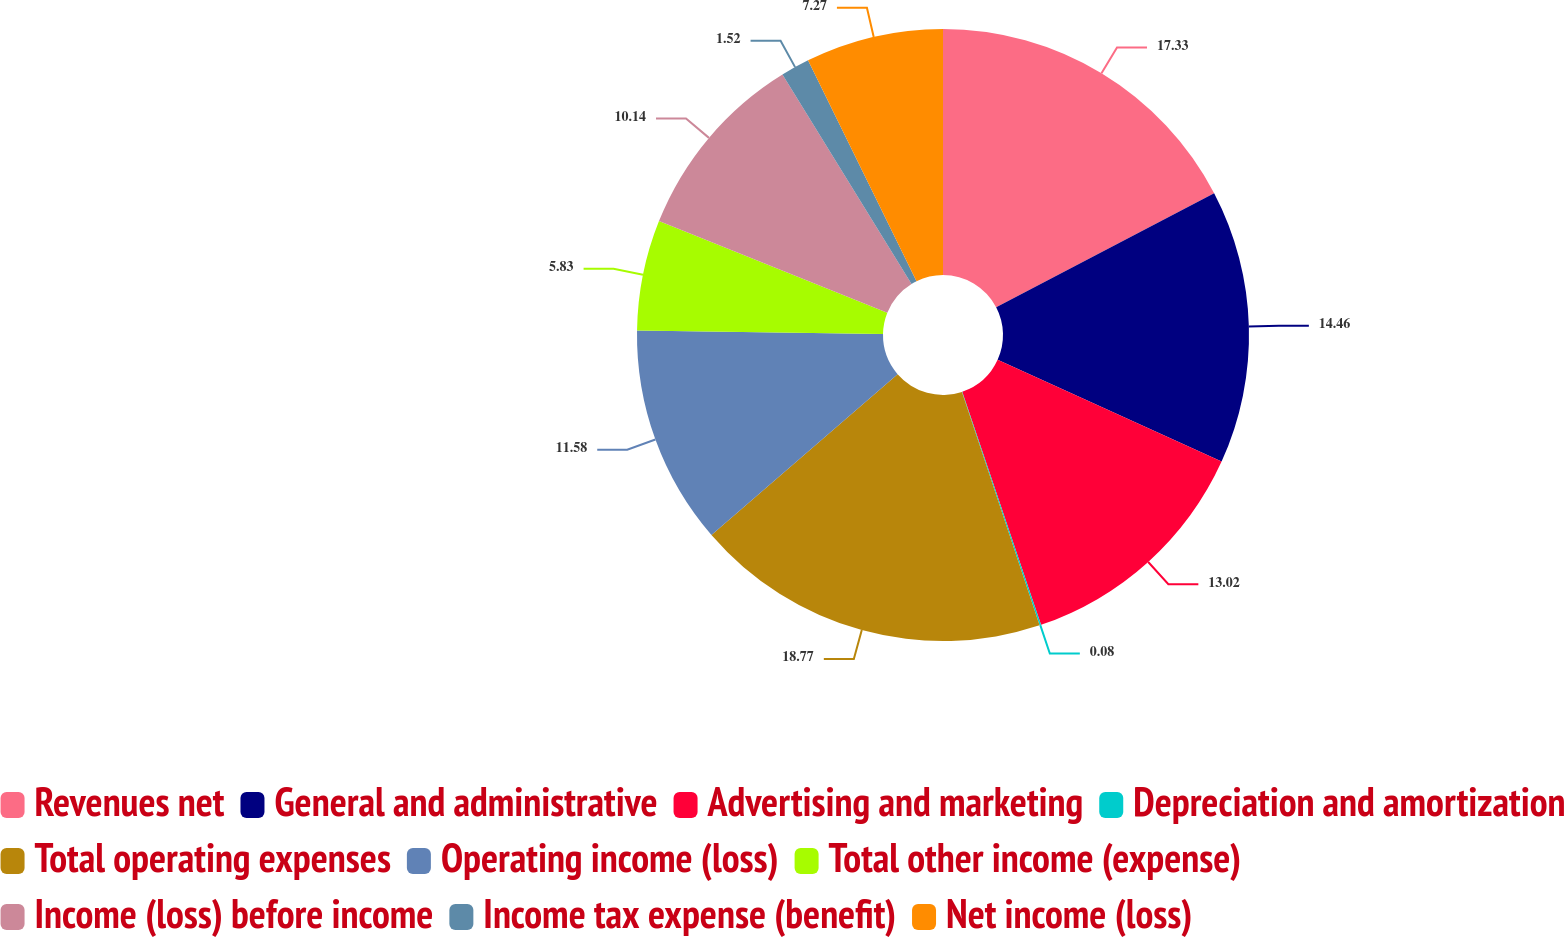<chart> <loc_0><loc_0><loc_500><loc_500><pie_chart><fcel>Revenues net<fcel>General and administrative<fcel>Advertising and marketing<fcel>Depreciation and amortization<fcel>Total operating expenses<fcel>Operating income (loss)<fcel>Total other income (expense)<fcel>Income (loss) before income<fcel>Income tax expense (benefit)<fcel>Net income (loss)<nl><fcel>17.33%<fcel>14.46%<fcel>13.02%<fcel>0.08%<fcel>18.77%<fcel>11.58%<fcel>5.83%<fcel>10.14%<fcel>1.52%<fcel>7.27%<nl></chart> 